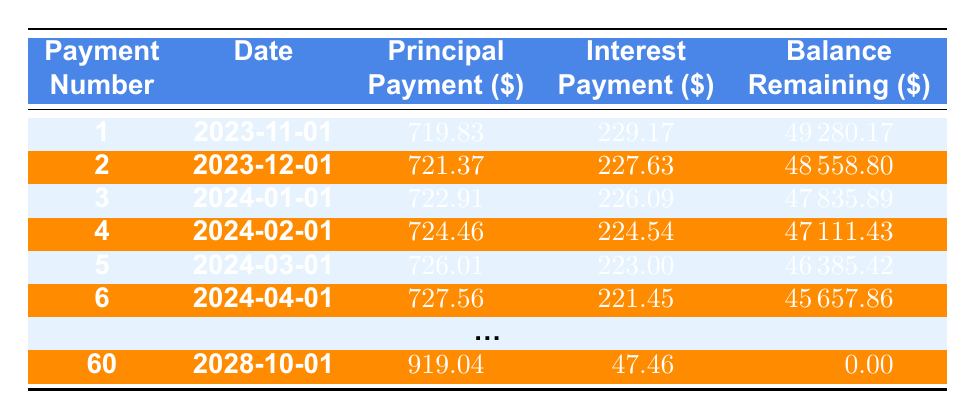What is the total loan amount? The loan amount is provided in the loan details at the top of the data. It states "loanAmount": 50000, which means the total loan amount is 50,000 dollars.
Answer: 50000 What is the interest payment for the second payment? The interest payment for the second payment can be found in the second row of the amortization schedule, marked by payment number 2. It states the interest payment is 227.63 dollars.
Answer: 227.63 How much was the principal payment made in the first month? Referencing the amortization schedule table under the first payment (payment number 1), the principal payment amount is listed as 719.83 dollars.
Answer: 719.83 Is the interest payment for payment number 4 greater than the principal payment for the same payment? The principal payment for payment number 4 is 724.46 dollars and the interest payment is 224.54 dollars. To determine if the interest payment is greater, we compare the two: 224.54 < 724.46. Therefore, the statement is false.
Answer: No What is the remaining balance after the third payment? The remaining balance after the third payment is found in the amortization schedule under payment number 3, which is 47835.89 dollars.
Answer: 47835.89 What is the total amount paid towards interest after the first six payments? To find the total interest paid after six payments, we will sum the individual interest payments from the first six rows of the table: 229.17 + 227.63 + 226.09 + 224.54 + 223.00 + 221.45 = 1,351.88. Thus, the total interest paid is 1,351.88 dollars.
Answer: 1351.88 How many payments remain after payment number 6? The total number of payments is 60 (as indicated in the data), and after payment number 6, there are 60 - 6 = 54 payments remaining. Therefore, there are 54 payments left.
Answer: 54 What was the highest amount paid towards principal in a single payment? To find this, we look at the principal payments listed in each row. The highest value is found in the last payment, number 60, which is 919.04 dollars. Hence, this is the highest amount paid towards principal in a single payment.
Answer: 919.04 What is the average interest payment for the first six months? The total interest payments for the first six months are: 229.17 + 227.63 + 226.09 + 224.54 + 223.00 + 221.45 = 1,351.88. To find the average, we divide the total by 6, yielding 1,351.88 / 6 = 225.31. Therefore, the average interest payment is approximately 225.31 dollars.
Answer: 225.31 